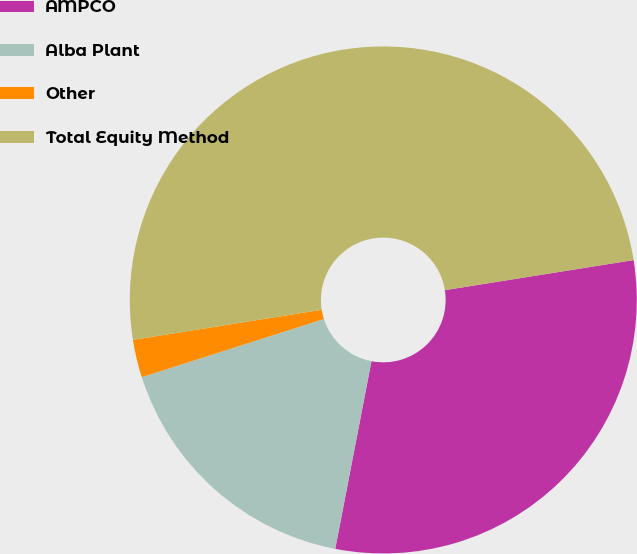<chart> <loc_0><loc_0><loc_500><loc_500><pie_chart><fcel>AMPCO<fcel>Alba Plant<fcel>Other<fcel>Total Equity Method<nl><fcel>30.55%<fcel>17.04%<fcel>2.41%<fcel>50.0%<nl></chart> 